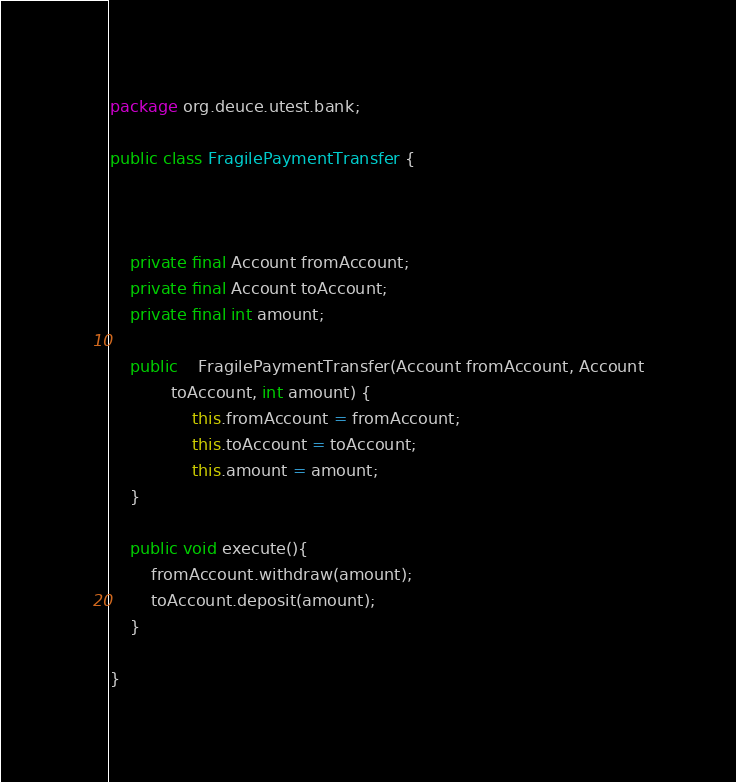Convert code to text. <code><loc_0><loc_0><loc_500><loc_500><_Java_>package org.deuce.utest.bank;

public class FragilePaymentTransfer {


	
	private final Account fromAccount;
	private final Account toAccount;
	private final int amount;

	public 	FragilePaymentTransfer(Account fromAccount, Account
			toAccount, int amount) {
				this.fromAccount = fromAccount;
				this.toAccount = toAccount;
				this.amount = amount;
	}

	public void execute(){
		fromAccount.withdraw(amount);
		toAccount.deposit(amount);
	}
	
}
</code> 